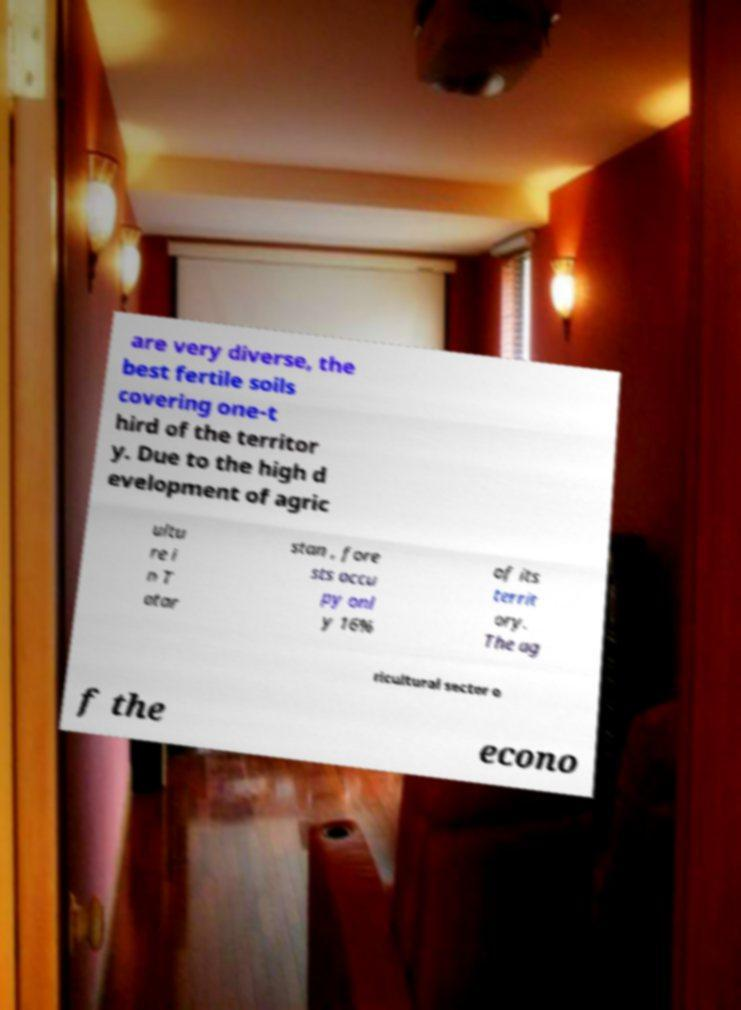What messages or text are displayed in this image? I need them in a readable, typed format. are very diverse, the best fertile soils covering one-t hird of the territor y. Due to the high d evelopment of agric ultu re i n T atar stan , fore sts occu py onl y 16% of its territ ory. The ag ricultural sector o f the econo 